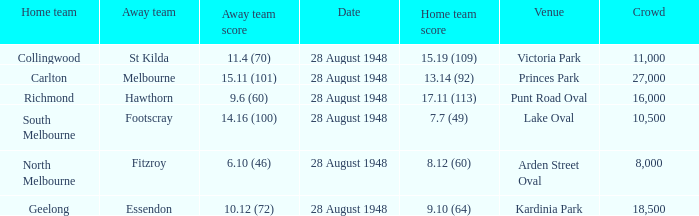What home team has a team score of 8.12 (60)? North Melbourne. 